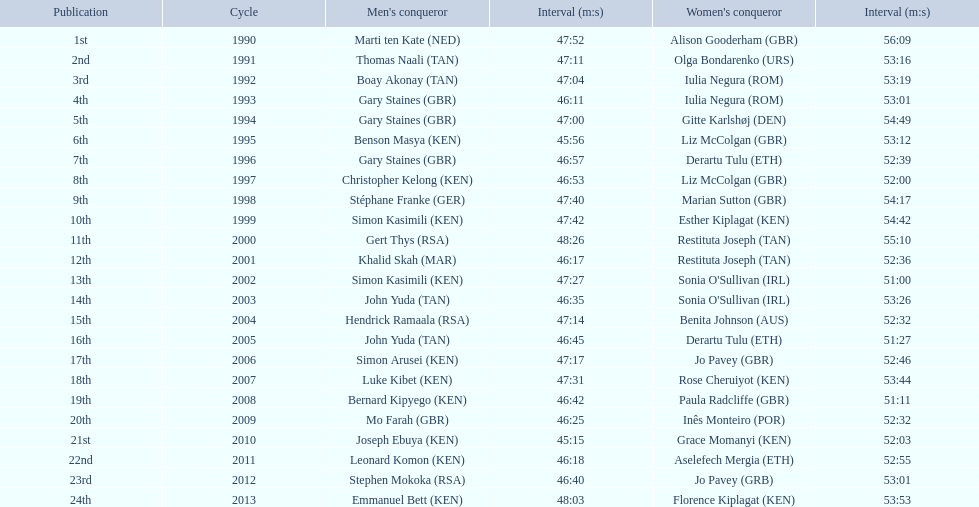What place did sonia o'sullivan finish in 2003? 14th. How long did it take her to finish? 53:26. 